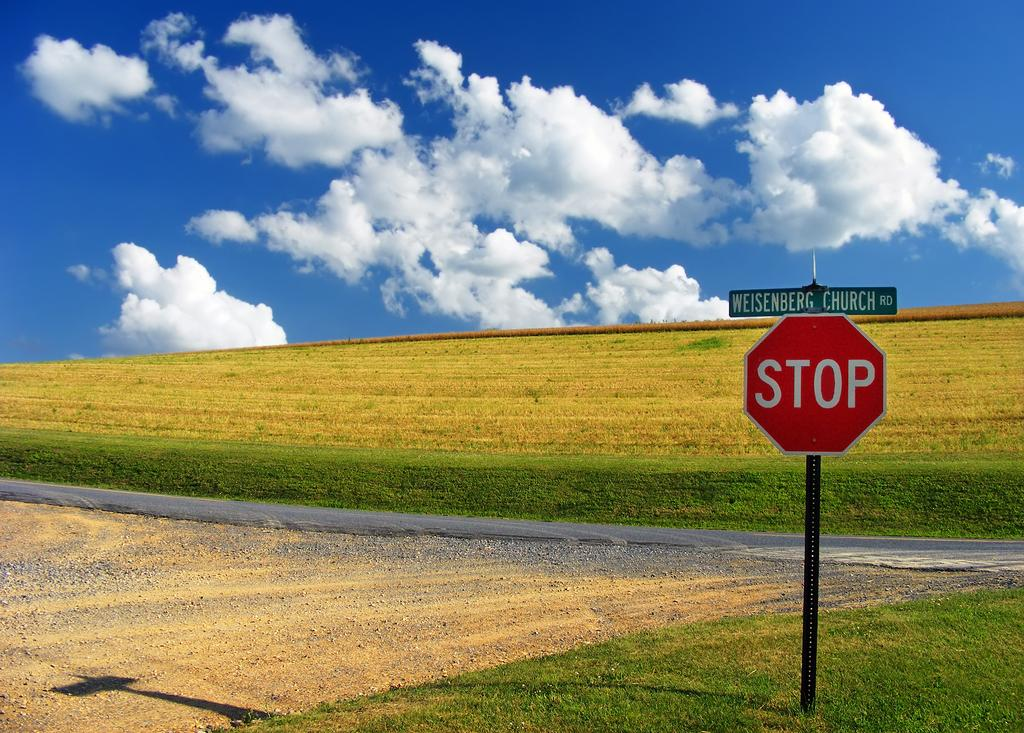What is the main object in the foreground of the image? There is a stop sign board in the foreground of the image. Where is the stop sign board located? The stop sign board is on the grass. What can be seen in the background of the image? There is a road, plants, and the sky visible in the background of the image. Can you describe the sky in the image? The sky is visible in the background of the image, and there is a cloud present. What type of stove can be seen in the image? There is no stove present in the image. How does the taste of the grass affect the appearance of the stop sign board? The taste of the grass does not affect the appearance of the stop sign board, as taste is a sensory experience and not related to visual appearance. 